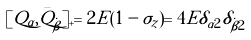Convert formula to latex. <formula><loc_0><loc_0><loc_500><loc_500>[ Q _ { \alpha } , \bar { Q } _ { \dot { \beta } } ] _ { + } = 2 E ( 1 - \sigma _ { z } ) = 4 E \delta _ { \alpha 2 } \delta _ { \dot { \beta } 2 }</formula> 